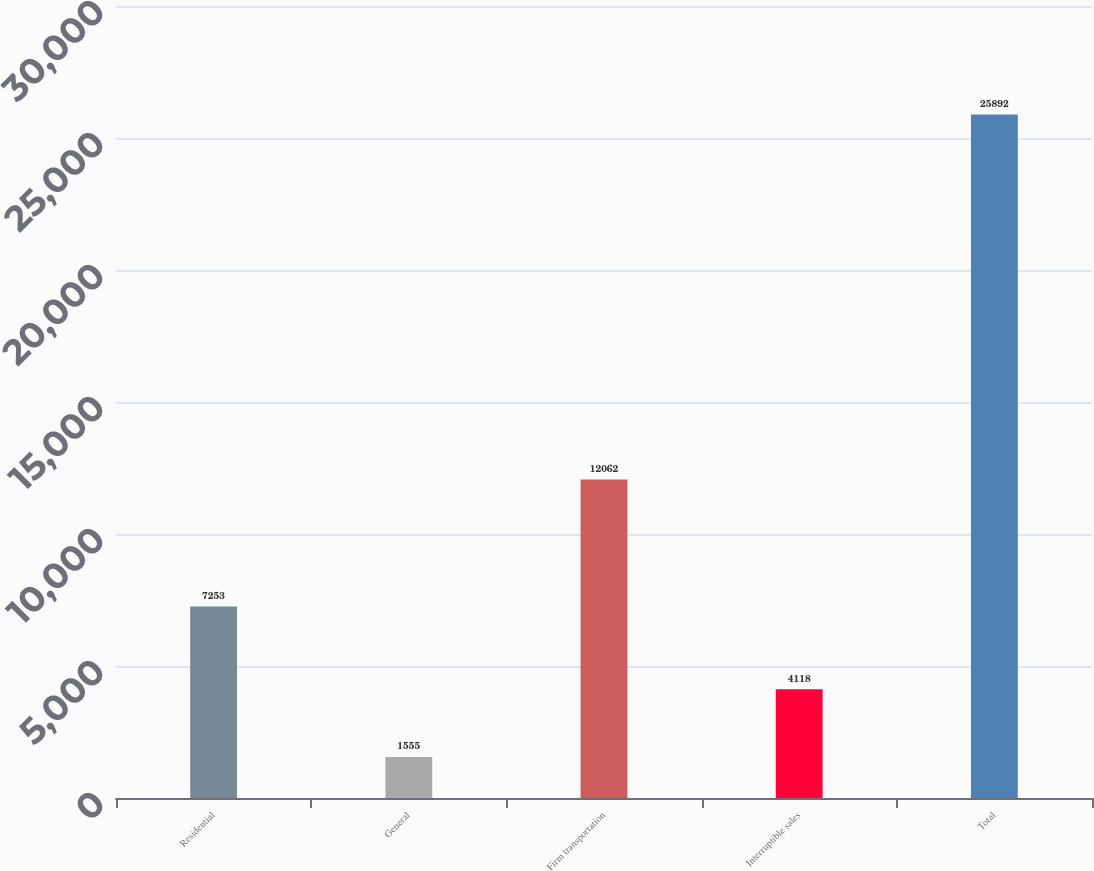Convert chart. <chart><loc_0><loc_0><loc_500><loc_500><bar_chart><fcel>Residential<fcel>General<fcel>Firm transportation<fcel>Interruptible sales<fcel>Total<nl><fcel>7253<fcel>1555<fcel>12062<fcel>4118<fcel>25892<nl></chart> 